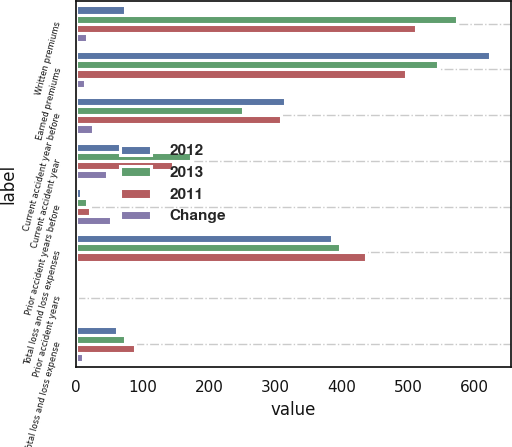Convert chart to OTSL. <chart><loc_0><loc_0><loc_500><loc_500><stacked_bar_chart><ecel><fcel>Written premiums<fcel>Earned premiums<fcel>Current accident year before<fcel>Current accident year<fcel>Prior accident years before<fcel>Total loss and loss expenses<fcel>Prior accident years<fcel>Total loss and loss expense<nl><fcel>2012<fcel>72.9<fcel>623<fcel>315<fcel>93<fcel>8<fcel>386<fcel>2.3<fcel>62<nl><fcel>2013<fcel>573<fcel>545<fcel>251<fcel>173<fcel>17<fcel>398<fcel>1.8<fcel>72.9<nl><fcel>2011<fcel>512<fcel>497<fcel>309<fcel>146<fcel>21<fcel>437<fcel>0.7<fcel>88.1<nl><fcel>Change<fcel>17<fcel>14<fcel>25<fcel>46<fcel>53<fcel>3<fcel>0.5<fcel>10.9<nl></chart> 